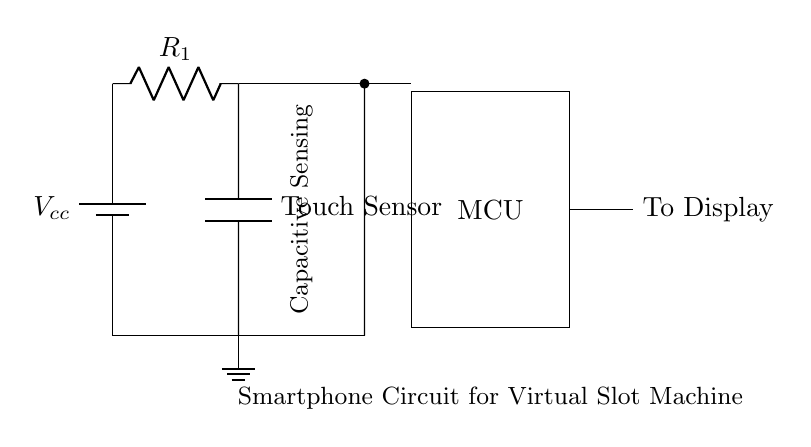What is the power source in this circuit? The power source in the circuit diagram is labeled as Vcc and is represented by a battery symbol.
Answer: Vcc What type of sensor is used in this circuit? The circuit diagram includes a component labeled as a Touch Sensor, indicating the type of sensor used to detect touch interactions.
Answer: Touch Sensor How many resistors are in the circuit? The circuit diagram shows one resistor labeled as R1, which is the only resistor present in the schematic.
Answer: One What is the function of the microcontroller in the circuit? The microcontroller (MCU) is connected to the touch sensor and display, suggesting its role is to process input from the touch sensor and control the output to the display based on that input.
Answer: Processing input What connects the touch sensor to the microcontroller? A direct connection is shown between the touch sensor and the microcontroller, indicating that the output from the touch sensor goes directly into the microcontroller for processing.
Answer: A wire Why is the ground important in this circuit? The ground is essential as it provides a common reference point for all voltage levels in the circuit, ensuring stable operation and return paths for the current flow.
Answer: Common reference 